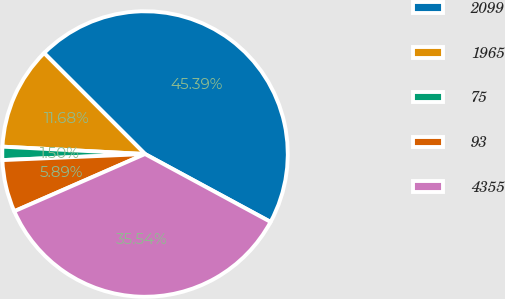Convert chart. <chart><loc_0><loc_0><loc_500><loc_500><pie_chart><fcel>2099<fcel>1965<fcel>75<fcel>93<fcel>4355<nl><fcel>45.39%<fcel>11.68%<fcel>1.5%<fcel>5.89%<fcel>35.54%<nl></chart> 